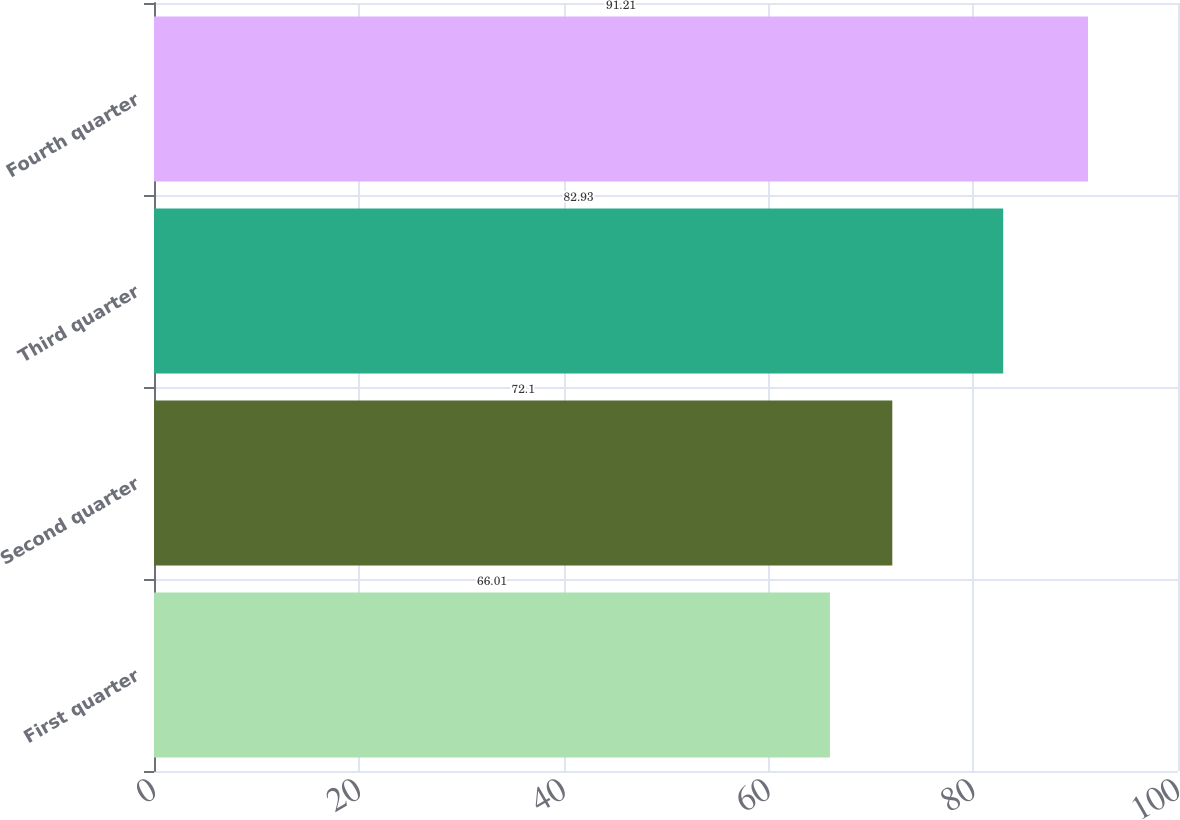Convert chart. <chart><loc_0><loc_0><loc_500><loc_500><bar_chart><fcel>First quarter<fcel>Second quarter<fcel>Third quarter<fcel>Fourth quarter<nl><fcel>66.01<fcel>72.1<fcel>82.93<fcel>91.21<nl></chart> 